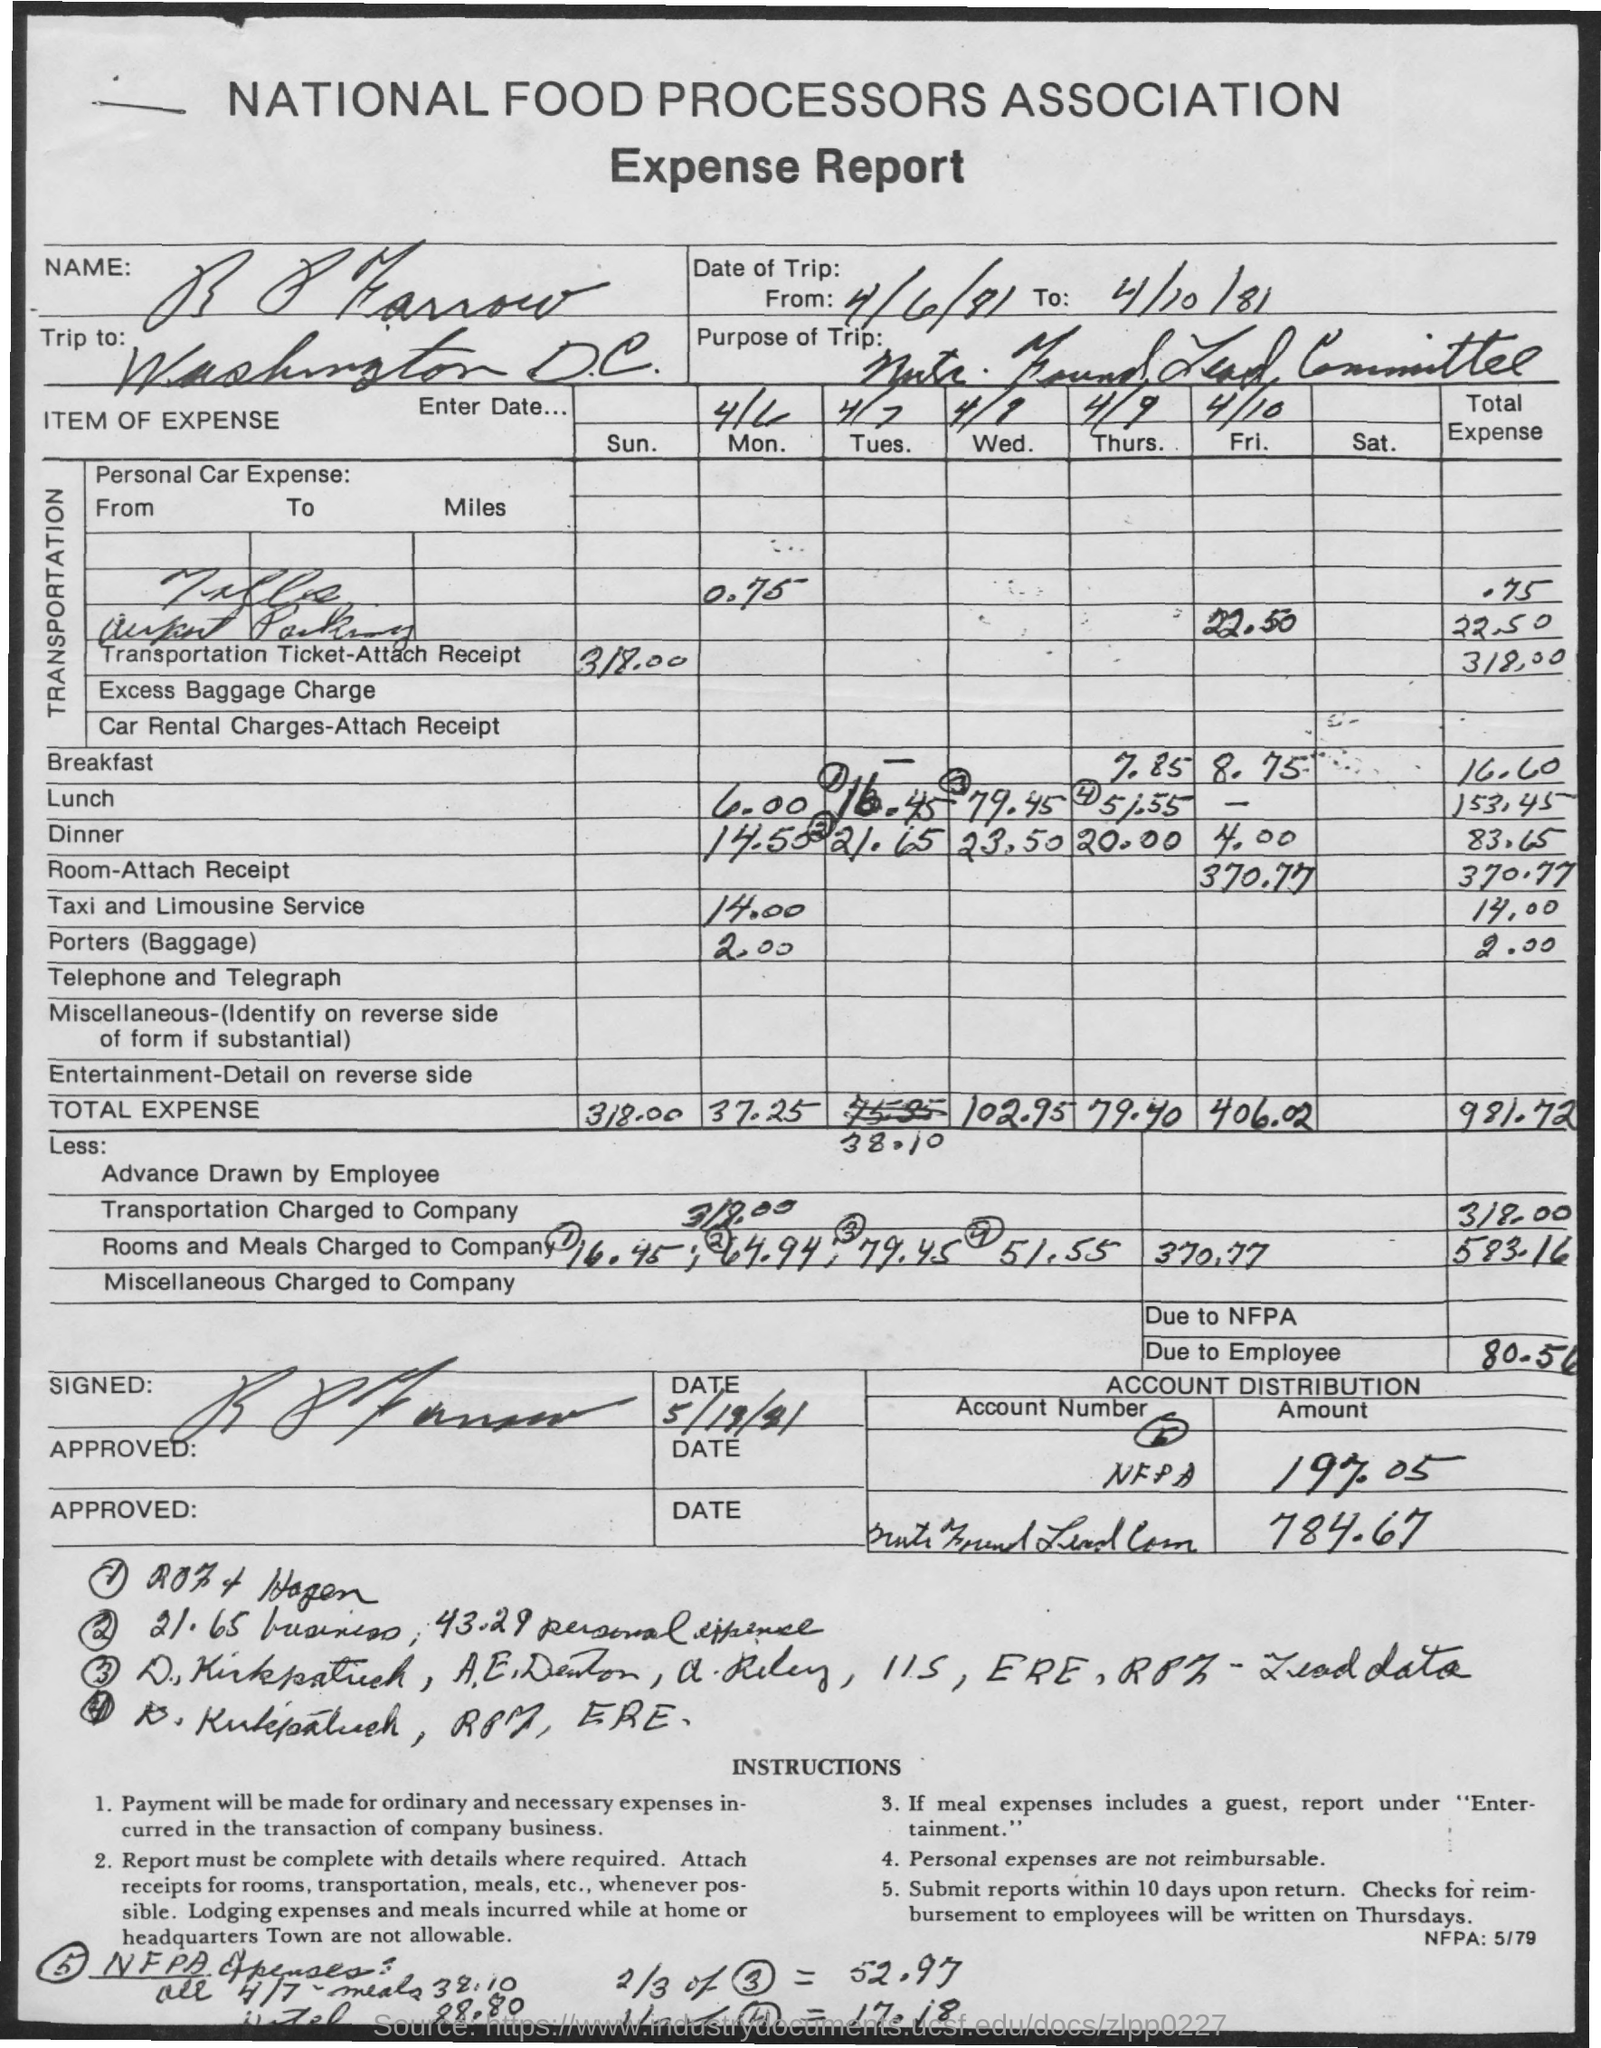What is due to the employee? Based on the expense report image provided, the employee is due $80.56. This total is calculated from various expenses related to transportation, meals, lodging, and miscellaneous costs incurred during a business trip, as itemized and totaled on the report. 